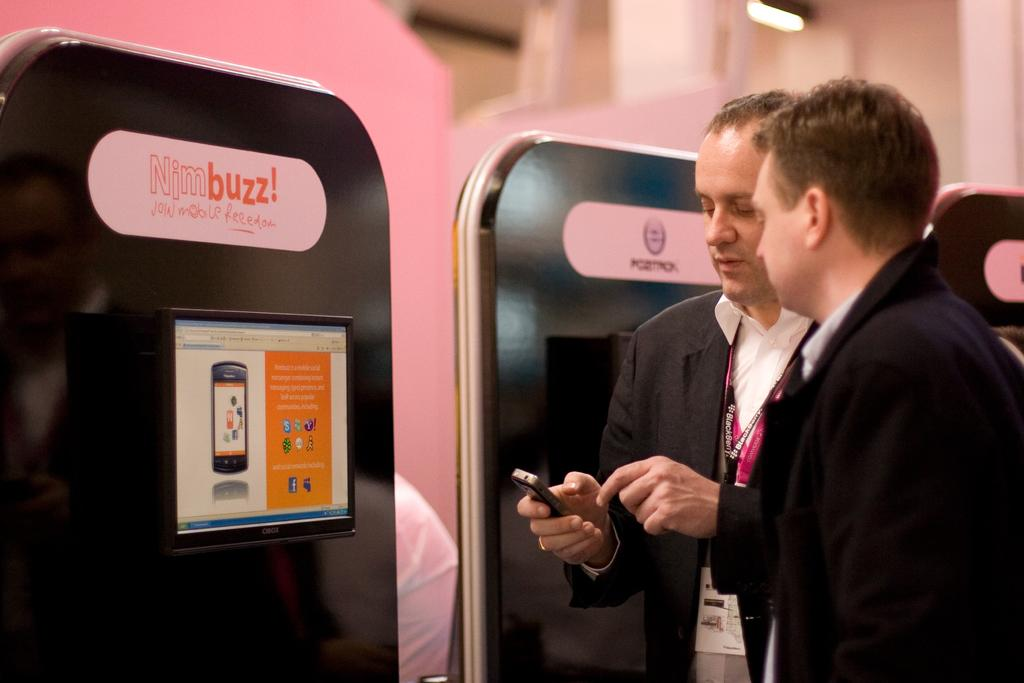How many people are in the image? There are two persons in the image. What are the persons doing in the image? The persons are standing and looking at a phone. What else can be seen in the image besides the persons? There is a board in the image. How many pages are in the book that the persons are reading in the image? There is no book present in the image; the persons are looking at a phone. 